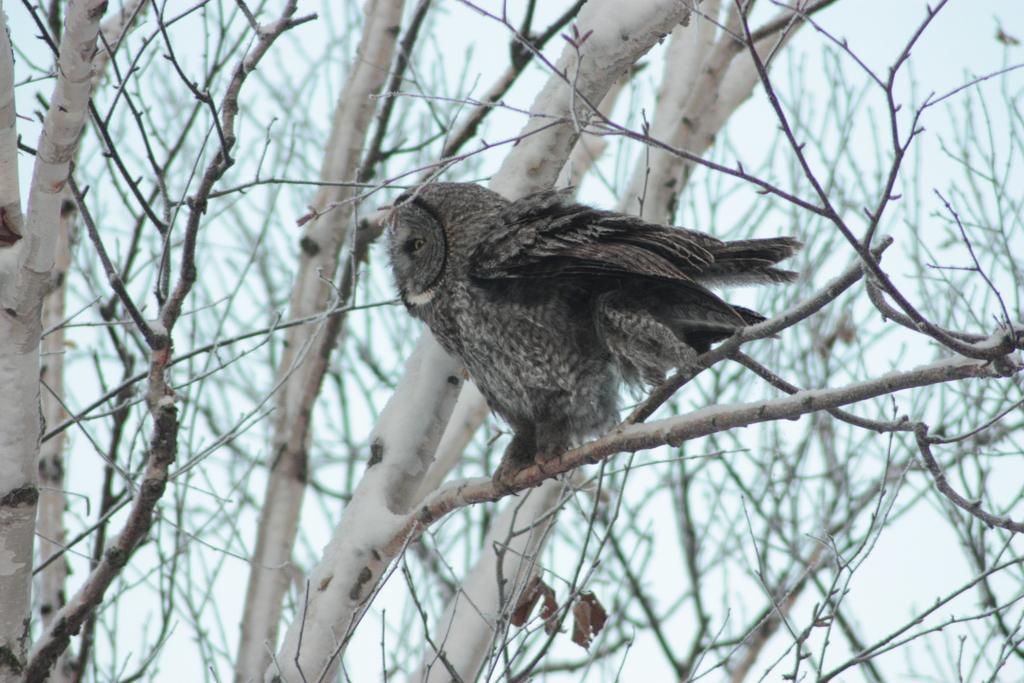Could you give a brief overview of what you see in this image? In this picture we can see trees, there is an owl in the front, we can see the sky in the background. 